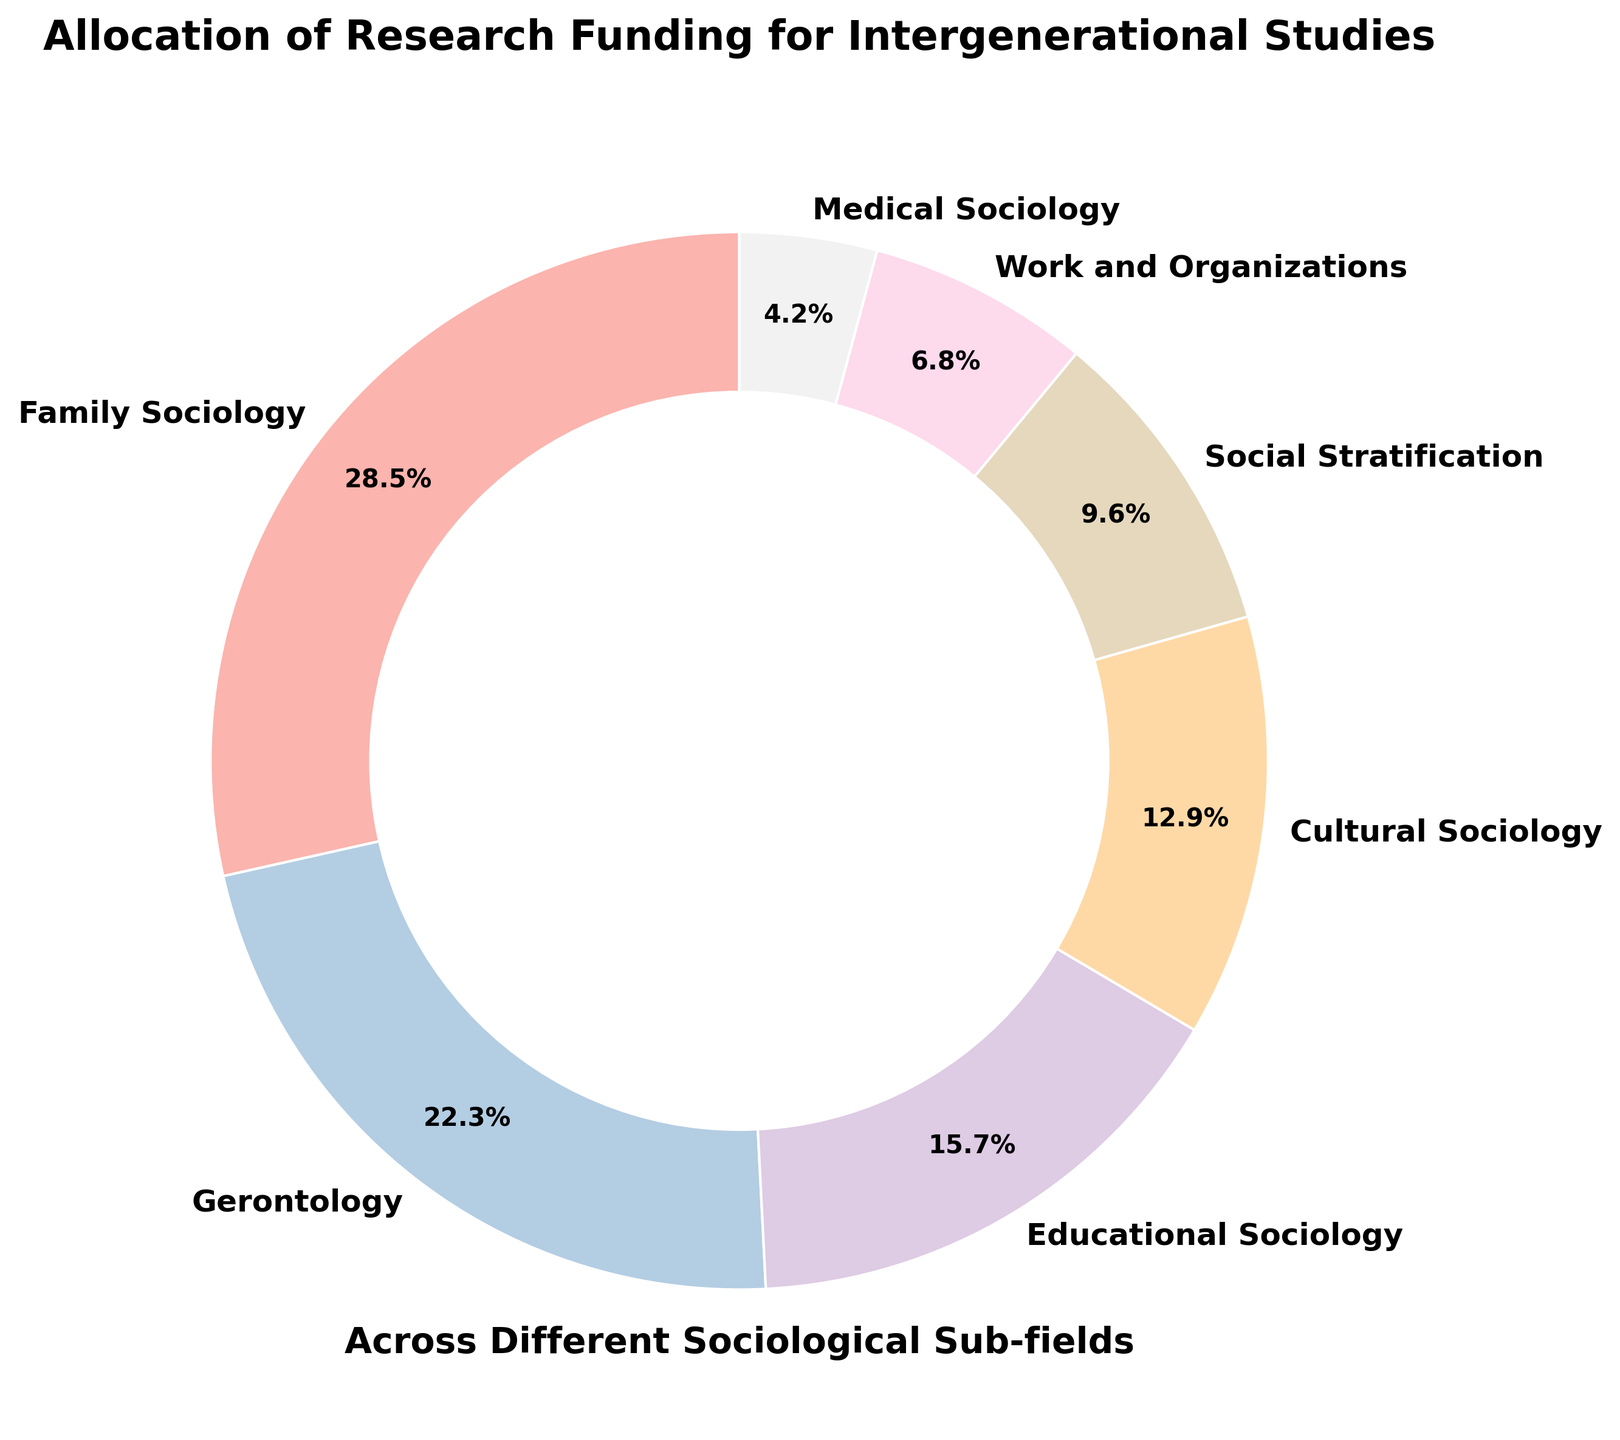What is the funding percentage allocated to Family Sociology? The label "Family Sociology" is present on the pie chart with a segment showing the percentage. Reading the label and percentage directly from the segment, we find it is 28.5%.
Answer: 28.5% Which sub-field receives the second highest funding allocation? To determine this, look at the sizes of the pie segments. The largest segment is Family Sociology with 28.5%. The second largest segment is Gerontology with 22.3%.
Answer: Gerontology What is the combined funding percentage for Social Stratification and Medical Sociology? Add the percentages for Social Stratification (9.6%) and Medical Sociology (4.2%). The combined funding is 9.6 + 4.2 = 13.8%.
Answer: 13.8% How does the funding for Educational Sociology compare to that of Cultural Sociology? The pie chart shows percentages for Educational Sociology (15.7%) and Cultural Sociology (12.9%). Compare these two values to see that Educational Sociology has a higher percentage.
Answer: Educational Sociology has higher funding Which sub-fields receive less than 10% funding? Check the segments whose percentages are labeled less than 10%. The sub-fields are Social Stratification (9.6%), Work and Organizations (6.8%), and Medical Sociology (4.2%).
Answer: Social Stratification, Work and Organizations, Medical Sociology What is the difference in funding percentage between Family Sociology and Work and Organizations? Subtract the percentage for Work and Organizations (6.8%) from Family Sociology (28.5%). The difference is 28.5 - 6.8 = 21.7%.
Answer: 21.7% What is the average funding percentage allocated to the sub-fields? Sum all the percentages for the sub-fields: 28.5 + 22.3 + 15.7 + 12.9 + 9.6 + 6.8 + 4.2 = 100. The average is 100/7 ≈ 14.29%.
Answer: 14.29% What color represents Gerontology on the pie chart? Identify the color assigned to the segment labeled "Gerontology." The custom colors are generated using a Pastel palette, typically showing light pastel shades.
Answer: Light pastel (exact color varies, typically a light shade) 